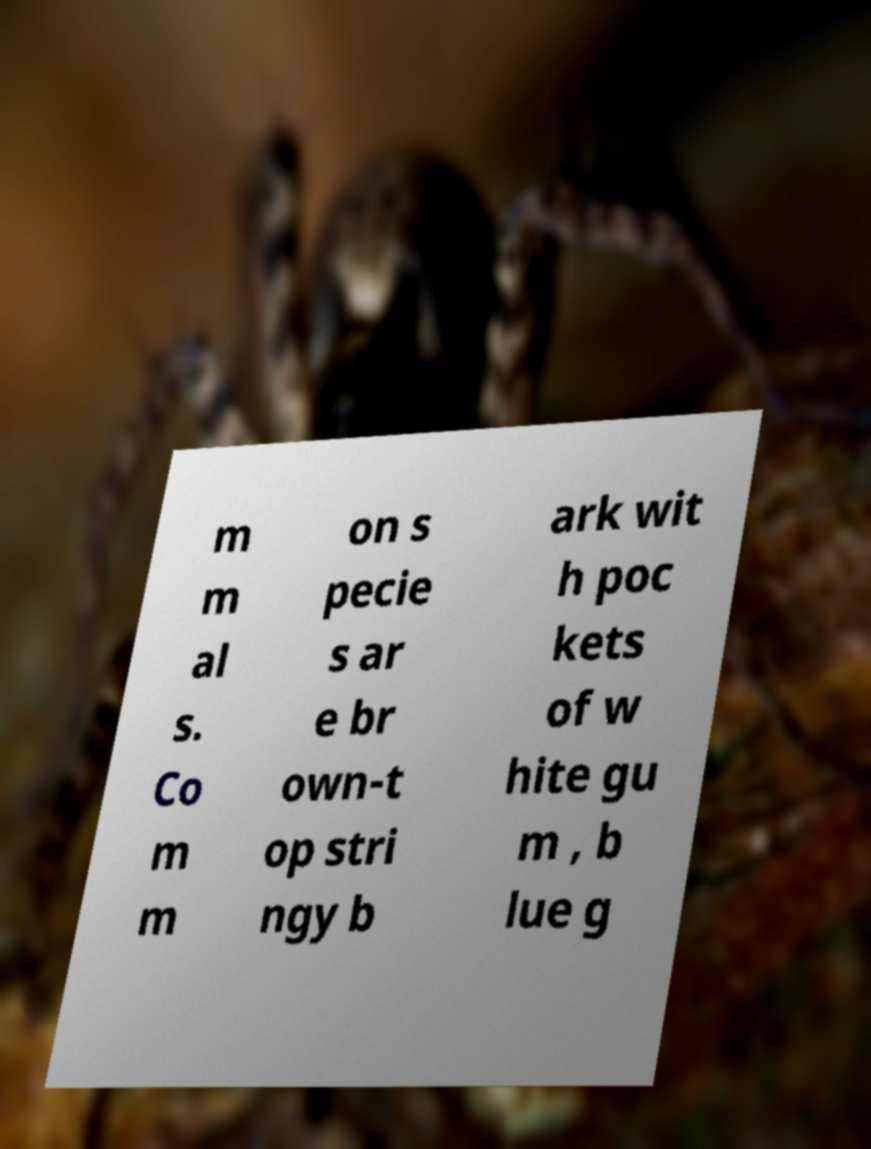Could you extract and type out the text from this image? m m al s. Co m m on s pecie s ar e br own-t op stri ngy b ark wit h poc kets of w hite gu m , b lue g 